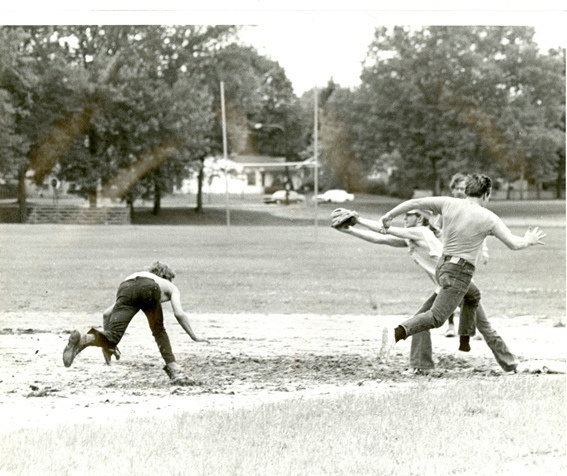Describe the objects in this image and their specific colors. I can see people in white, ivory, darkgray, gray, and black tones, people in white, black, ivory, gray, and darkgray tones, people in white, ivory, gray, darkgray, and darkgreen tones, people in white, lightgray, darkgray, and gray tones, and car in white, darkgray, and gray tones in this image. 